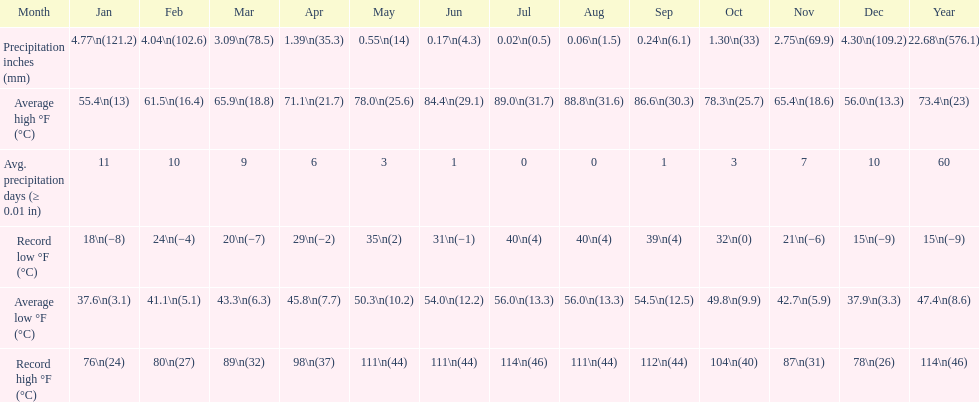0 degrees and the mean low hit 5 July. 